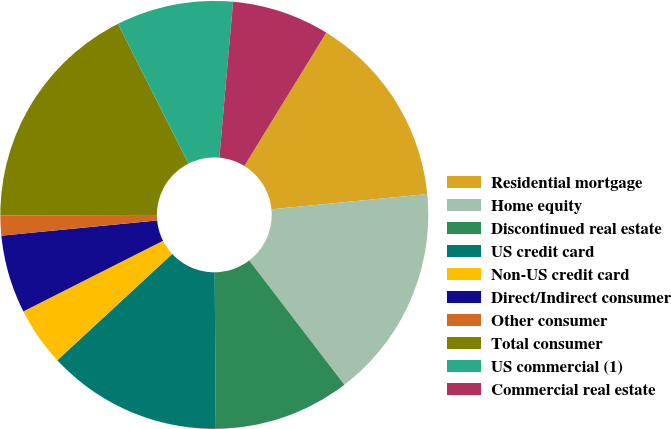Convert chart to OTSL. <chart><loc_0><loc_0><loc_500><loc_500><pie_chart><fcel>Residential mortgage<fcel>Home equity<fcel>Discontinued real estate<fcel>US credit card<fcel>Non-US credit card<fcel>Direct/Indirect consumer<fcel>Other consumer<fcel>Total consumer<fcel>US commercial (1)<fcel>Commercial real estate<nl><fcel>14.68%<fcel>16.15%<fcel>10.29%<fcel>13.22%<fcel>4.44%<fcel>5.9%<fcel>1.51%<fcel>17.61%<fcel>8.83%<fcel>7.37%<nl></chart> 